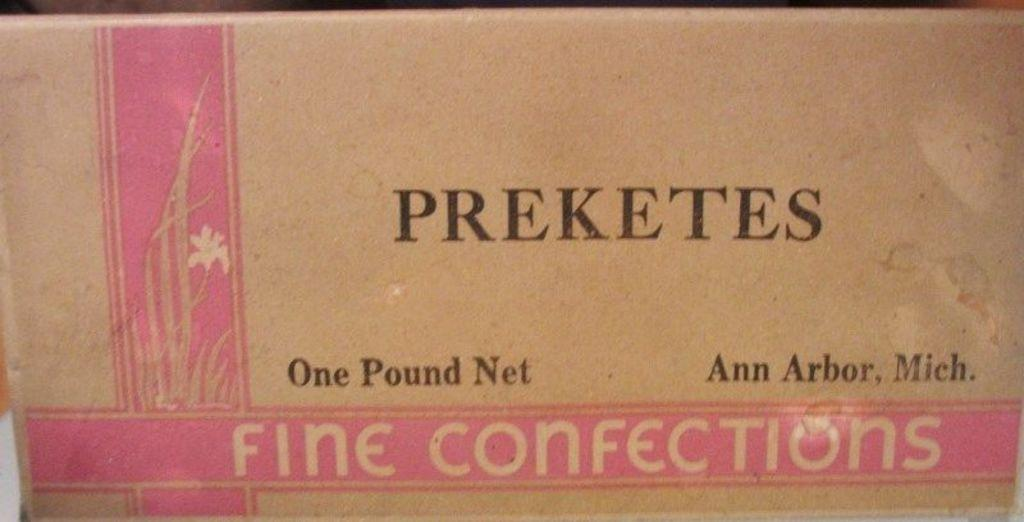<image>
Relay a brief, clear account of the picture shown. A cardboard pakaging for Preketes Fine confections with a pink logo on the left. 